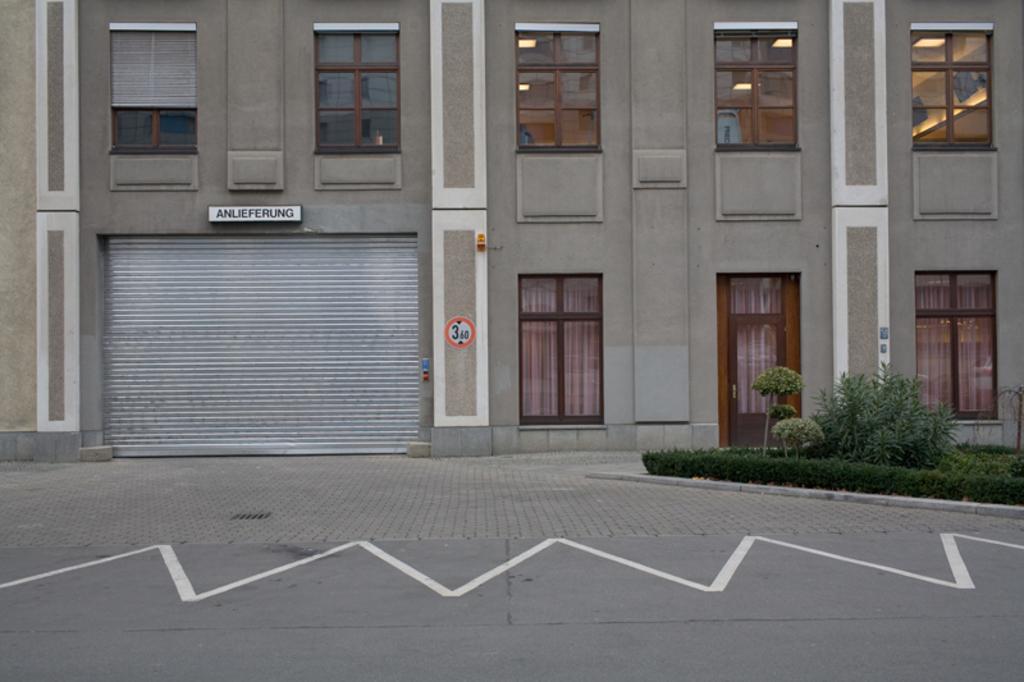Could you give a brief overview of what you see in this image? In this image I can see the road, few plants which are green in color and a building which is grey and white in color. I can see the rolling shutter which is grey in color, few windows of the building and through the windows I can see few curtains and few lights. 